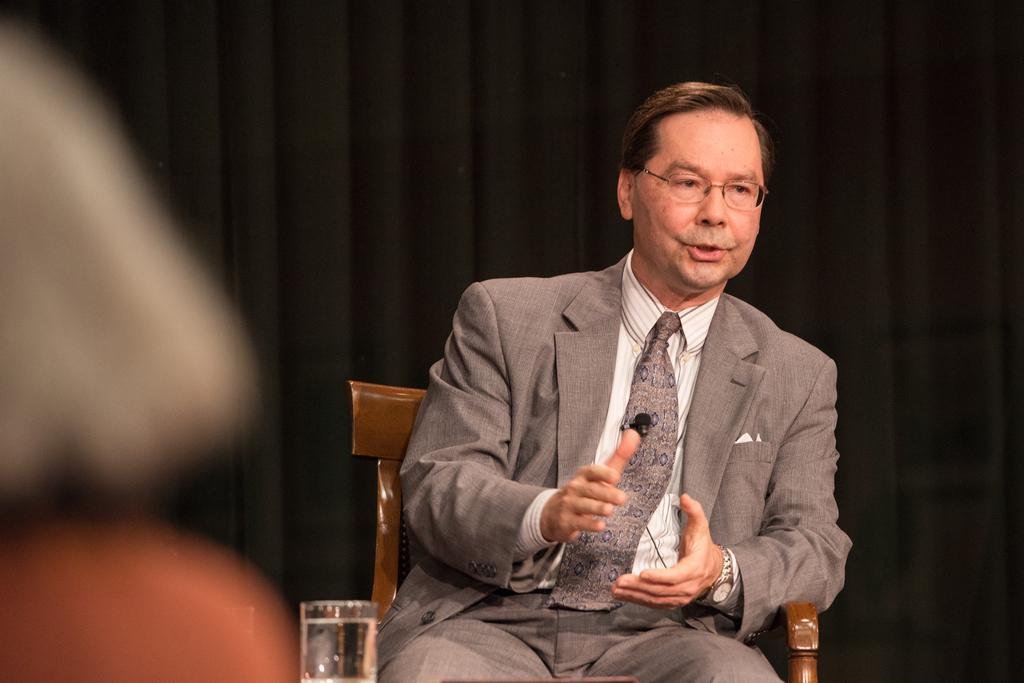Describe this image in one or two sentences. In this image there is a person wearing a suit and tie. He is sitting on the chair. He is wearing spectacles. Bottom of the image there is a glass which is filled with water. Background there is a curtain. Left side of the image is blur. 